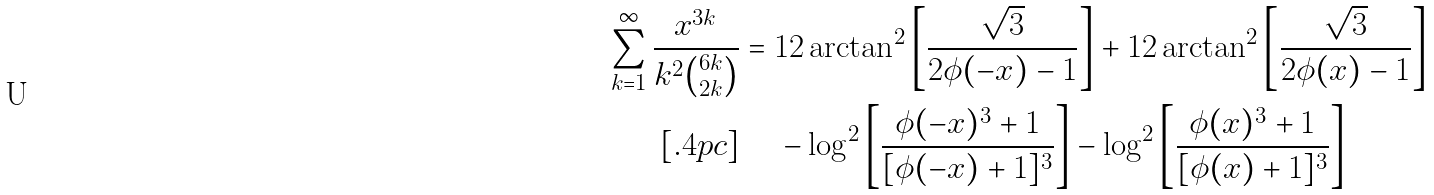Convert formula to latex. <formula><loc_0><loc_0><loc_500><loc_500>\sum _ { k = 1 } ^ { \infty } \frac { x ^ { 3 k } } { k ^ { 2 } \binom { 6 k } { 2 k } } & = 1 2 \arctan ^ { 2 } \left [ { \frac { \sqrt { 3 } } { 2 \phi ( - x ) - 1 } } \right ] + 1 2 \arctan ^ { 2 } \left [ { \frac { \sqrt { 3 } } { 2 \phi ( x ) - 1 } } \right ] \\ [ . 4 p c ] & \quad \, - \log ^ { 2 } \left [ { \frac { \phi ( - x ) ^ { 3 } + 1 } { [ \phi ( - x ) + 1 ] ^ { 3 } } } \right ] - \log ^ { 2 } \left [ { \frac { \phi ( x ) ^ { 3 } + 1 } { [ \phi ( x ) + 1 ] ^ { 3 } } } \right ]</formula> 